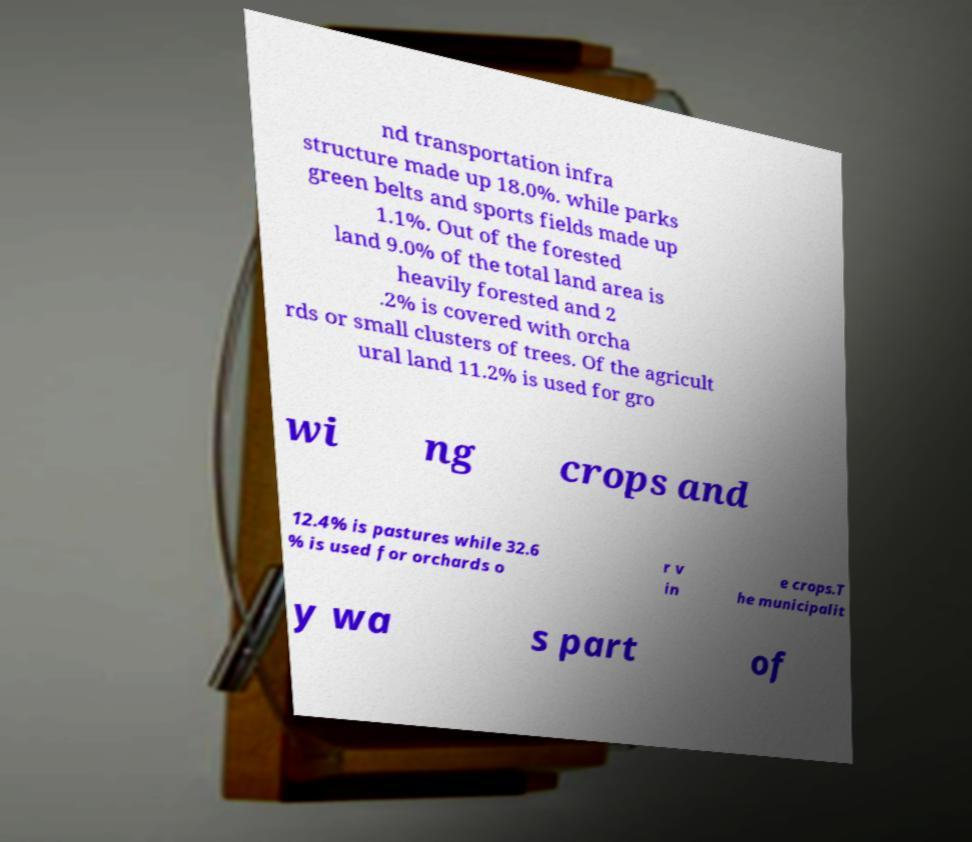There's text embedded in this image that I need extracted. Can you transcribe it verbatim? nd transportation infra structure made up 18.0%. while parks green belts and sports fields made up 1.1%. Out of the forested land 9.0% of the total land area is heavily forested and 2 .2% is covered with orcha rds or small clusters of trees. Of the agricult ural land 11.2% is used for gro wi ng crops and 12.4% is pastures while 32.6 % is used for orchards o r v in e crops.T he municipalit y wa s part of 